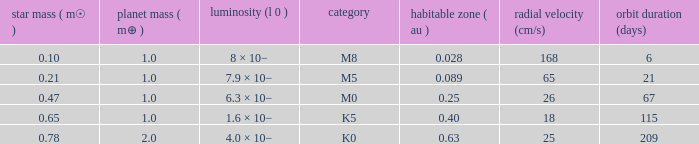What is the total stellar mass of the type m0? 0.47. 